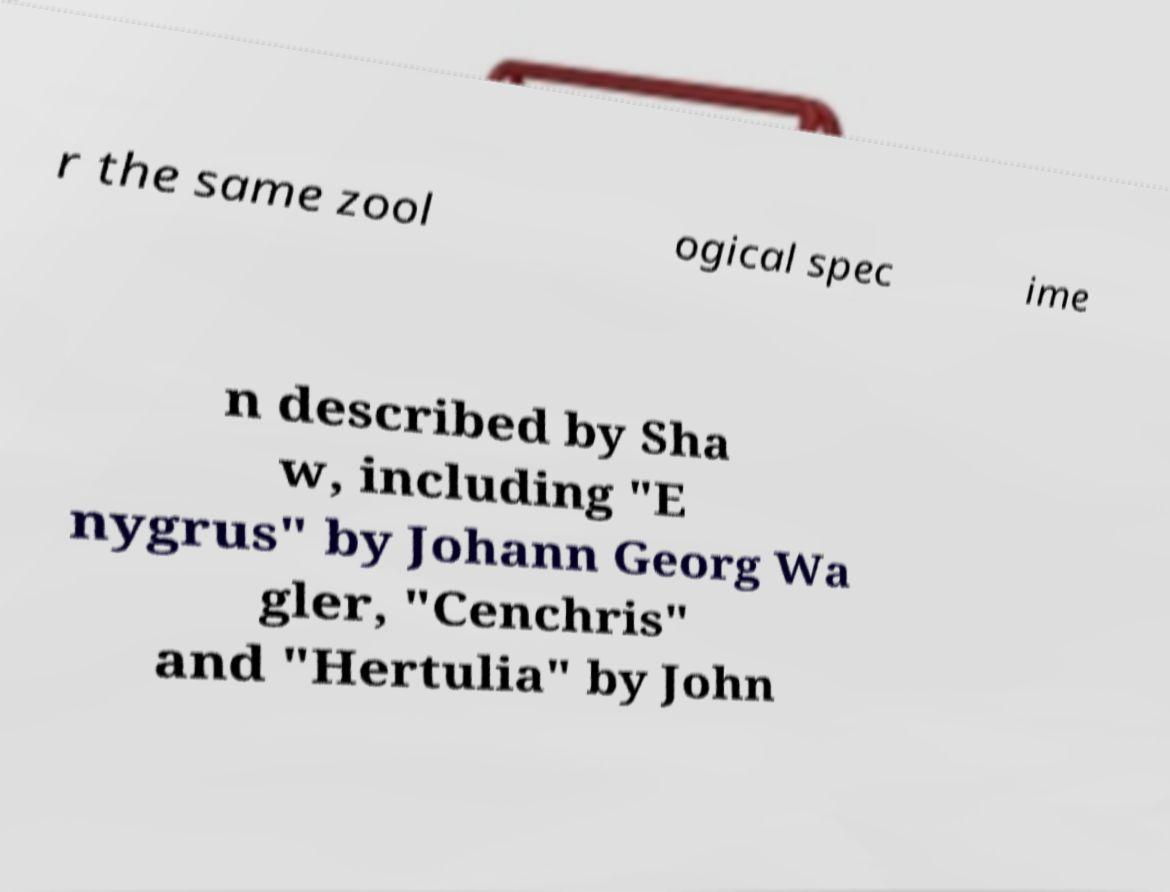For documentation purposes, I need the text within this image transcribed. Could you provide that? r the same zool ogical spec ime n described by Sha w, including "E nygrus" by Johann Georg Wa gler, "Cenchris" and "Hertulia" by John 